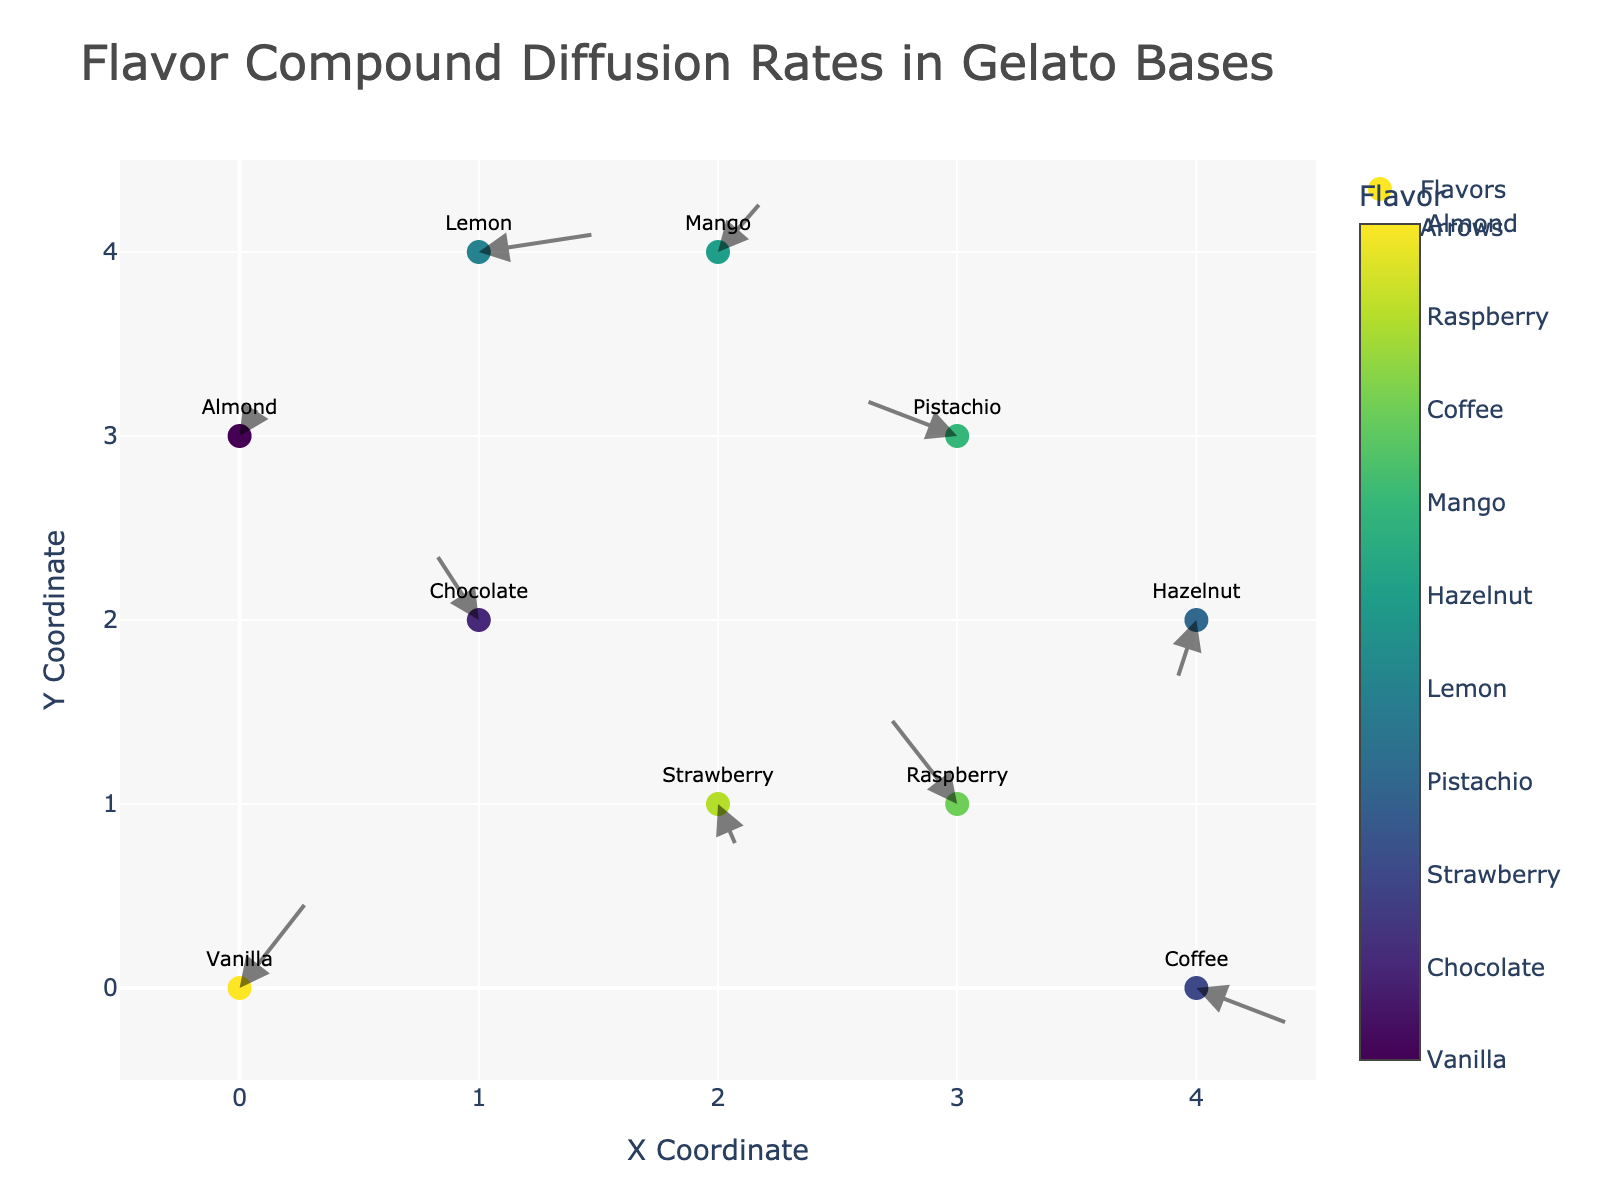What's the title of the figure? The title of the figure is written at the top and usually in a larger font size to easily catch the viewer's attention. In this case, the title is "Flavor Compound Diffusion Rates in Gelato Bases."
Answer: Flavor Compound Diffusion Rates in Gelato Bases How many unique flavors are represented in the plot? To determine the number of unique flavors, observe the different text labels next to each data point. Here, we can count flavors like Vanilla, Chocolate, Strawberry, etc.
Answer: 10 Which flavor has the highest X coordinate, and what is that coordinate? Look at the X-axis and find the flavor with the largest X value. From the data, Coffee has the highest X coordinate value of 4.
Answer: Coffee, 4 Which flavors have negative diffusion rates in both X and Y directions? Negative diffusion rates in both X and Y can be spotted by arrows pointing to the down-left direction. From the data (u, v values), Chocolate and Hazelnut both have negative rates in both X and Y.
Answer: Chocolate, Hazelnut What's the average X coordinate of all flavors? Sum all the X coordinates and divide by the number of flavors. (0 + 1 + 2 + 3 + 1 + 4 + 2 + 4 + 3 + 0) / 10 = 2.0
Answer: 2.0 Which flavor has the largest magnitude of diffusion rate considering both X and Y components? The magnitude of the vector (u, v) can be determined by sqrt(u^2 + v^2). Calculate for each flavor and find the largest one. Raspberry has the largest magnitude √((-0.3)^2 + 0.5^2) ≈ 0.583
Answer: Raspberry Which flavors have arrows pointing directly upwards? Arrows pointing directly upwards has u = 0 while v > 0. From the dataset, no flavor has exactly u = 0; hence no arrows point directly upwards.
Answer: None What is the color of the marker representing Mango and what does it signify? The color is determined by the colorscale and will correspond to Mango's category code. The specific color represents Mango in the categorized colorscale.
Answer: Specific color for Mango in the colorscale Which flavor's diffusion vector points towards the top right quadrant? Diffusion vectors pointing towards the top right quadrant have both u > 0 and v > 0. From the data, Vanilla (u=0.3, v=0.5), Lemon (u=0.5, v=0.1), and Mango (u=0.2, v=0.3) point towards the top right.
Answer: Vanilla, Lemon, Mango 